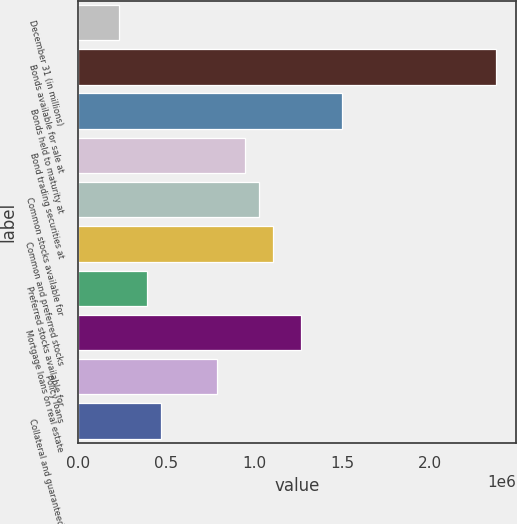Convert chart to OTSL. <chart><loc_0><loc_0><loc_500><loc_500><bar_chart><fcel>December 31 (in millions)<fcel>Bonds available for sale at<fcel>Bonds held to maturity at<fcel>Bond trading securities at<fcel>Common stocks available for<fcel>Common and preferred stocks<fcel>Preferred stocks available for<fcel>Mortgage loans on real estate<fcel>Policy loans<fcel>Collateral and guaranteed<nl><fcel>237304<fcel>2.37106e+06<fcel>1.50175e+06<fcel>948556<fcel>1.02758e+06<fcel>1.10661e+06<fcel>395360<fcel>1.26467e+06<fcel>790500<fcel>474388<nl></chart> 